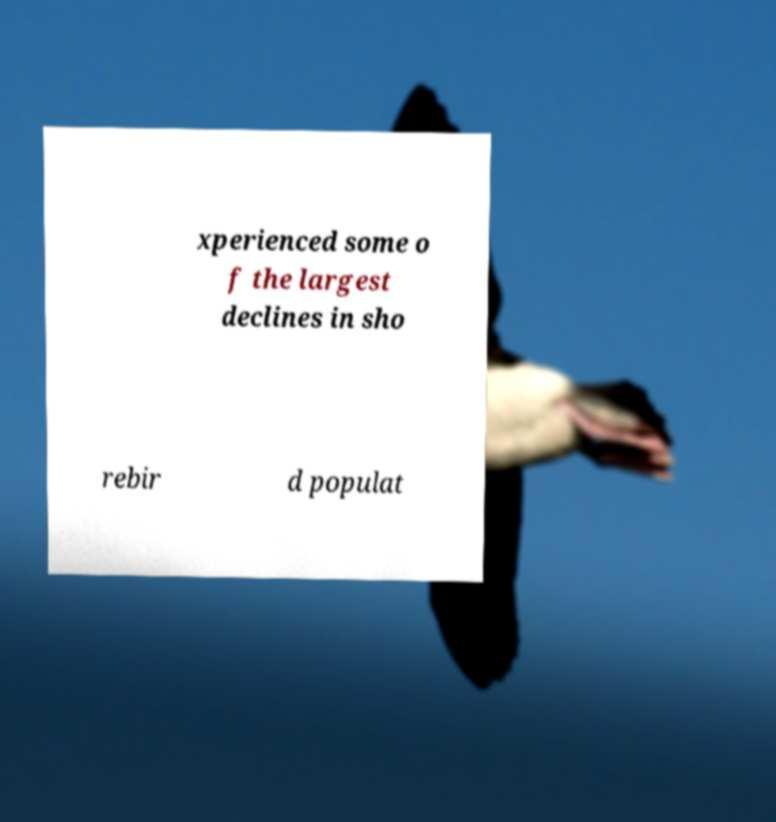Please read and relay the text visible in this image. What does it say? xperienced some o f the largest declines in sho rebir d populat 